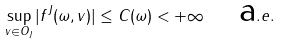<formula> <loc_0><loc_0><loc_500><loc_500>\sup _ { v \in O _ { J } } | f ^ { J } ( \omega , v ) | \leq C ( \omega ) < + \infty \quad \mbox a . e .</formula> 